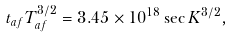Convert formula to latex. <formula><loc_0><loc_0><loc_500><loc_500>t _ { a f } T _ { a f } ^ { 3 / 2 } = 3 . 4 5 \times 1 0 ^ { 1 8 } \sec K ^ { 3 / 2 } ,</formula> 